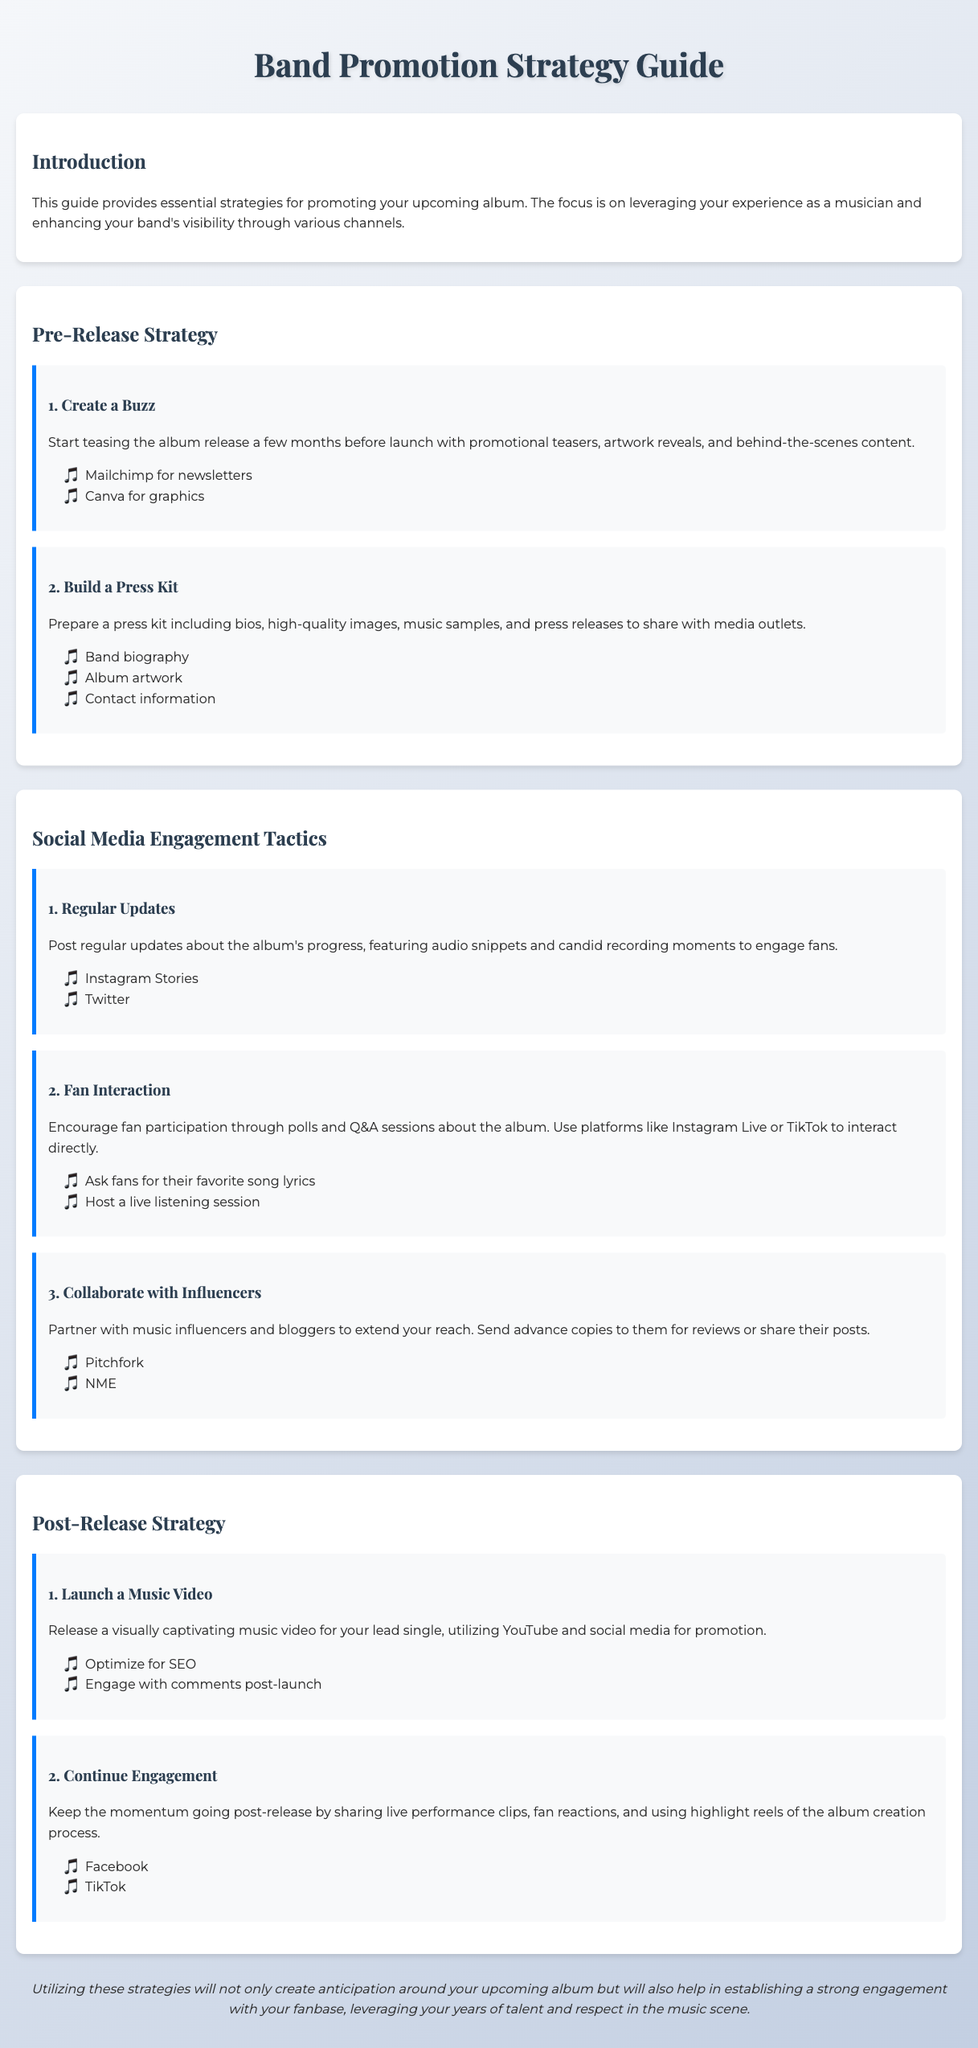what is the title of the guide? The title of the document is at the top section, indicating the overall topic of the content.
Answer: Band Promotion Strategy Guide how many main sections are in the guide? The sections are numbered in the introduction, providing clear distinctions between different parts of the content.
Answer: 4 which platform is suggested for mail newsletters? The platform is mentioned in the section focusing on creating buzz prior to the album release.
Answer: Mailchimp name one tactic for fan interaction. The document lists specific strategies under the social media engagement tactics section that facilitate direct communication with fans.
Answer: Polls what type of content should be included in a press kit? The document lists items that are essential for a press kit under the Pre-Release Strategy section.
Answer: High-quality images which social media platform is recommended for live interactions? The document specifies which platforms to use for engaging directly with fans through live sessions.
Answer: Instagram Live what is one way to create buzz for the album? The guidance in the document outlines specific actions that can help generate excitement prior to the album launch.
Answer: Promotional teasers what is suggested for post-release engagement? The document provides strategies that can help maintain fan interest after the album is released.
Answer: Share live performance clips 